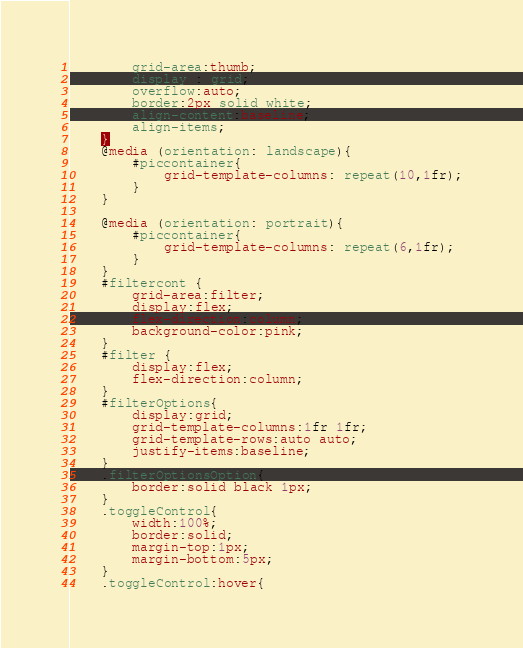<code> <loc_0><loc_0><loc_500><loc_500><_CSS_>		grid-area:thumb;
		display : grid;
		overflow:auto;
		border:2px solid white;
		align-content:baseline;
		align-items;
	}
	@media (orientation: landscape){
		#piccontainer{
			grid-template-columns: repeat(10,1fr);
		}
	}

	@media (orientation: portrait){
		#piccontainer{
			grid-template-columns: repeat(6,1fr);
		}
	}
	#filtercont {
		grid-area:filter;
		display:flex;
		flex-direction:column;
		background-color:pink;
	}
	#filter {
		display:flex;
		flex-direction:column;
	}
	#filterOptions{
		display:grid;
		grid-template-columns:1fr 1fr;
		grid-template-rows:auto auto;
		justify-items:baseline;
	}
	.filterOptionsOption{
		border:solid black 1px;
	}
	.toggleControl{
		width:100%;
		border:solid;
		margin-top:1px;
		margin-bottom:5px;
	}
	.toggleControl:hover{</code> 